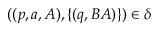<formula> <loc_0><loc_0><loc_500><loc_500>( ( p , a , A ) , \{ ( q , B A ) \} ) \in \delta</formula> 